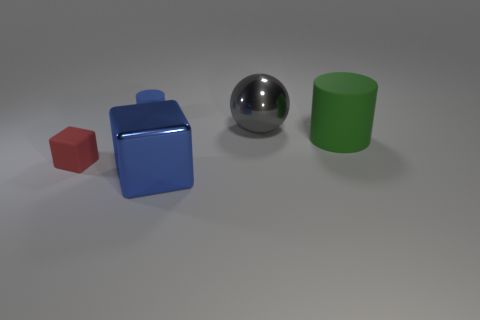Add 4 red metal balls. How many objects exist? 9 Subtract all balls. How many objects are left? 4 Add 4 shiny cubes. How many shiny cubes are left? 5 Add 2 large metal objects. How many large metal objects exist? 4 Subtract 0 green spheres. How many objects are left? 5 Subtract all large cyan matte blocks. Subtract all tiny blue things. How many objects are left? 4 